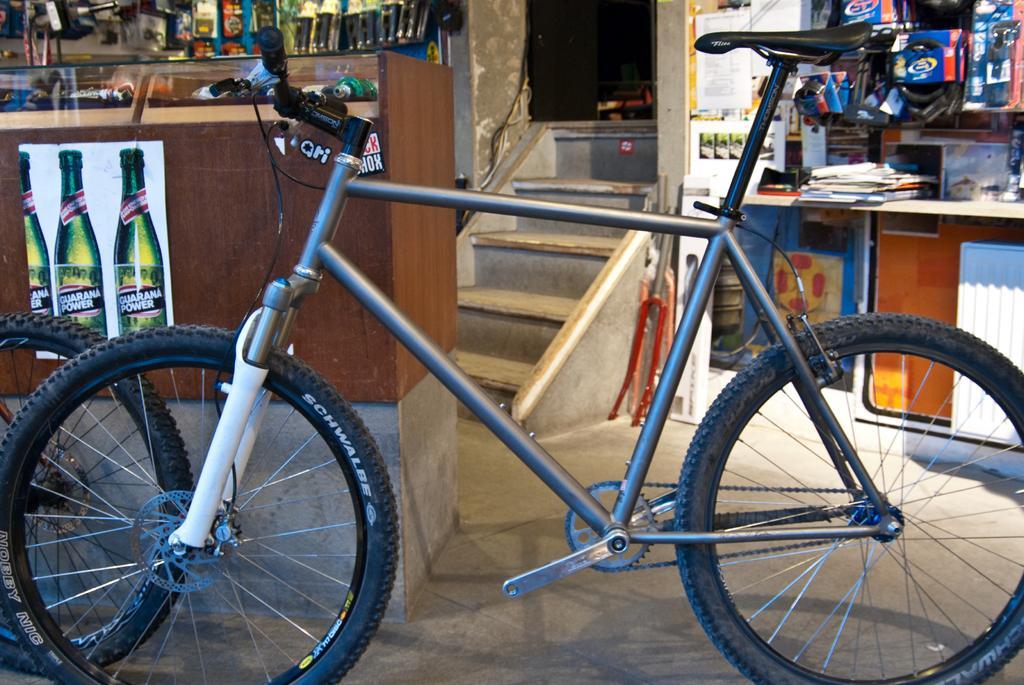Describe this image in one or two sentences. In the picture I can see a bicycle, a poster on which I can see green color bottles and a table here. Here I can see the steps in the background. Here I can see few objects placed here on the left side of the image. 